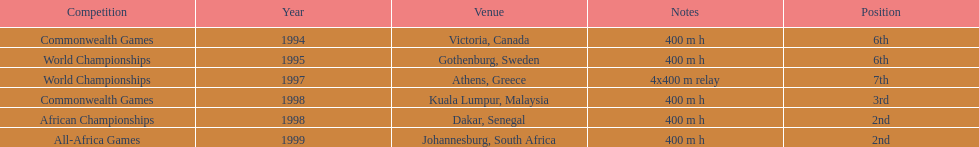How long was the relay at the 1997 world championships that ken harden ran 4x400 m relay. 